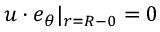Convert formula to latex. <formula><loc_0><loc_0><loc_500><loc_500>u \cdot e _ { \theta } | _ { r = R - 0 } = 0</formula> 